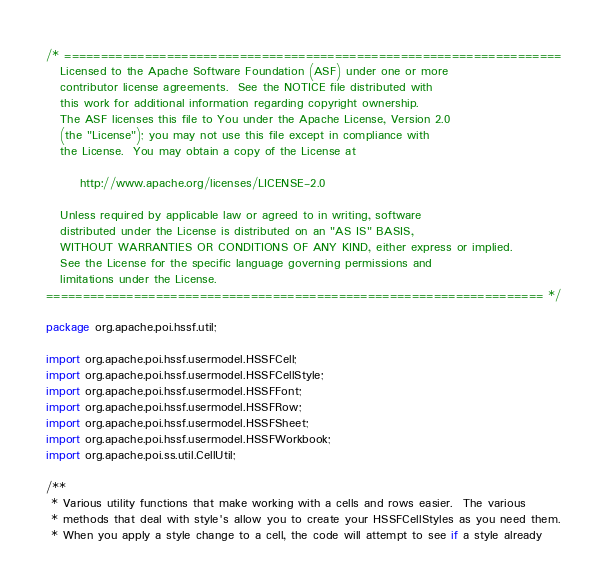<code> <loc_0><loc_0><loc_500><loc_500><_Java_>/* ====================================================================
   Licensed to the Apache Software Foundation (ASF) under one or more
   contributor license agreements.  See the NOTICE file distributed with
   this work for additional information regarding copyright ownership.
   The ASF licenses this file to You under the Apache License, Version 2.0
   (the "License"); you may not use this file except in compliance with
   the License.  You may obtain a copy of the License at

       http://www.apache.org/licenses/LICENSE-2.0

   Unless required by applicable law or agreed to in writing, software
   distributed under the License is distributed on an "AS IS" BASIS,
   WITHOUT WARRANTIES OR CONDITIONS OF ANY KIND, either express or implied.
   See the License for the specific language governing permissions and
   limitations under the License.
==================================================================== */

package org.apache.poi.hssf.util;

import org.apache.poi.hssf.usermodel.HSSFCell;
import org.apache.poi.hssf.usermodel.HSSFCellStyle;
import org.apache.poi.hssf.usermodel.HSSFFont;
import org.apache.poi.hssf.usermodel.HSSFRow;
import org.apache.poi.hssf.usermodel.HSSFSheet;
import org.apache.poi.hssf.usermodel.HSSFWorkbook;
import org.apache.poi.ss.util.CellUtil;

/**
 * Various utility functions that make working with a cells and rows easier.  The various
 * methods that deal with style's allow you to create your HSSFCellStyles as you need them.
 * When you apply a style change to a cell, the code will attempt to see if a style already</code> 